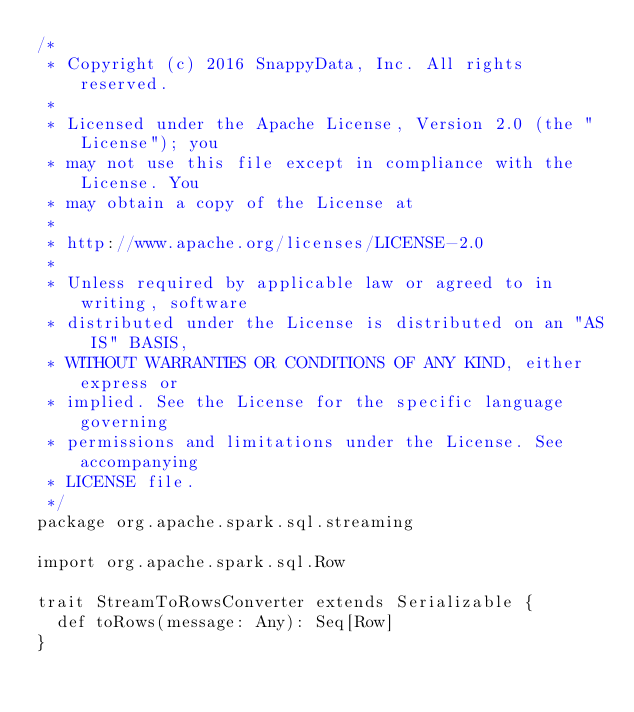Convert code to text. <code><loc_0><loc_0><loc_500><loc_500><_Scala_>/*
 * Copyright (c) 2016 SnappyData, Inc. All rights reserved.
 *
 * Licensed under the Apache License, Version 2.0 (the "License"); you
 * may not use this file except in compliance with the License. You
 * may obtain a copy of the License at
 *
 * http://www.apache.org/licenses/LICENSE-2.0
 *
 * Unless required by applicable law or agreed to in writing, software
 * distributed under the License is distributed on an "AS IS" BASIS,
 * WITHOUT WARRANTIES OR CONDITIONS OF ANY KIND, either express or
 * implied. See the License for the specific language governing
 * permissions and limitations under the License. See accompanying
 * LICENSE file.
 */
package org.apache.spark.sql.streaming

import org.apache.spark.sql.Row

trait StreamToRowsConverter extends Serializable {
  def toRows(message: Any): Seq[Row]
}


</code> 